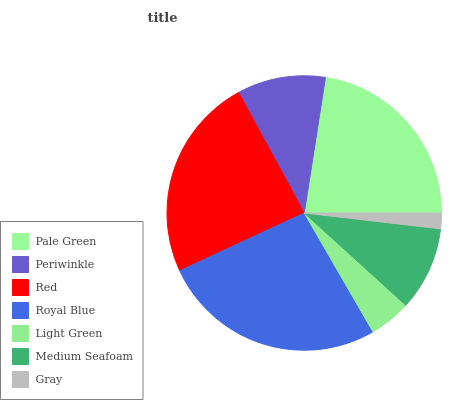Is Gray the minimum?
Answer yes or no. Yes. Is Royal Blue the maximum?
Answer yes or no. Yes. Is Periwinkle the minimum?
Answer yes or no. No. Is Periwinkle the maximum?
Answer yes or no. No. Is Pale Green greater than Periwinkle?
Answer yes or no. Yes. Is Periwinkle less than Pale Green?
Answer yes or no. Yes. Is Periwinkle greater than Pale Green?
Answer yes or no. No. Is Pale Green less than Periwinkle?
Answer yes or no. No. Is Periwinkle the high median?
Answer yes or no. Yes. Is Periwinkle the low median?
Answer yes or no. Yes. Is Light Green the high median?
Answer yes or no. No. Is Gray the low median?
Answer yes or no. No. 